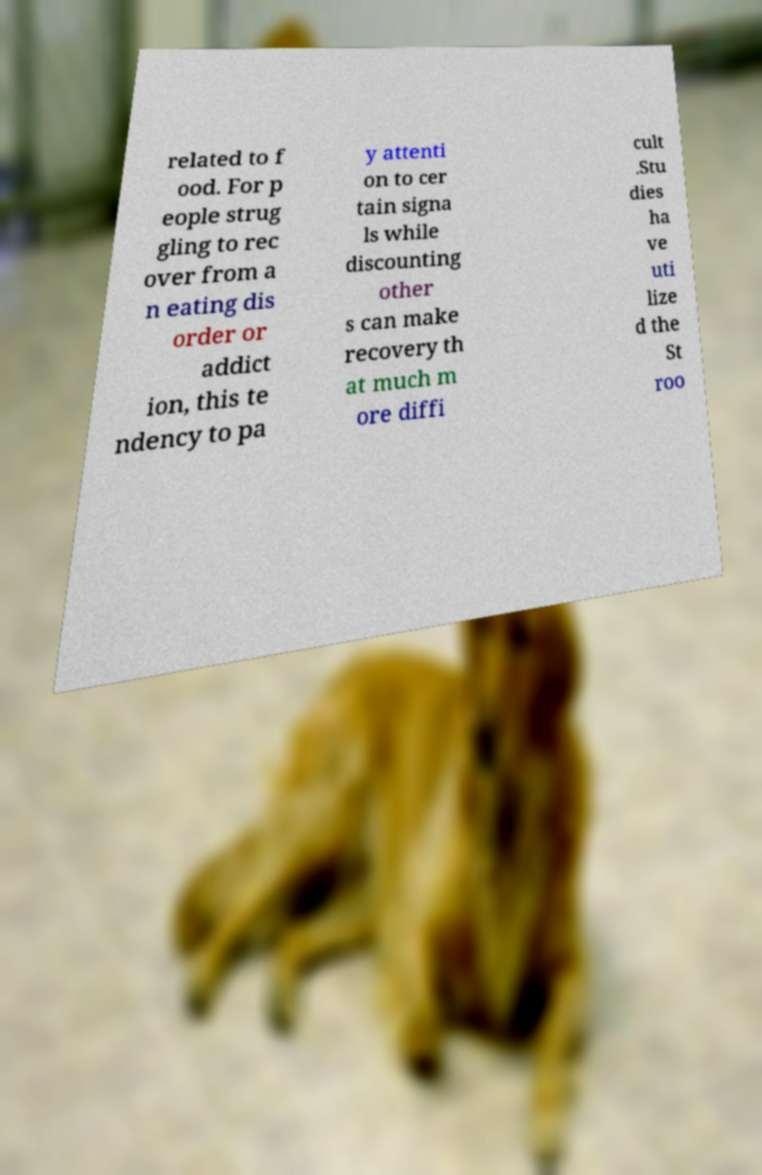What messages or text are displayed in this image? I need them in a readable, typed format. related to f ood. For p eople strug gling to rec over from a n eating dis order or addict ion, this te ndency to pa y attenti on to cer tain signa ls while discounting other s can make recovery th at much m ore diffi cult .Stu dies ha ve uti lize d the St roo 